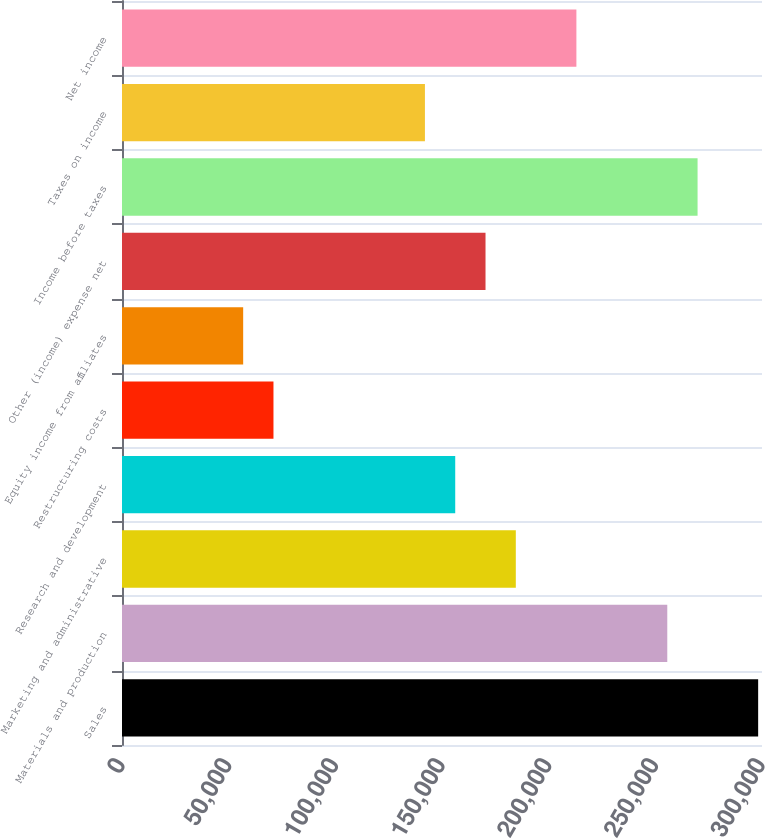<chart> <loc_0><loc_0><loc_500><loc_500><bar_chart><fcel>Sales<fcel>Materials and production<fcel>Marketing and administrative<fcel>Research and development<fcel>Restructuring costs<fcel>Equity income from affiliates<fcel>Other (income) expense net<fcel>Income before taxes<fcel>Taxes on income<fcel>Net income<nl><fcel>298198<fcel>255599<fcel>184599<fcel>156200<fcel>71000.9<fcel>56801.1<fcel>170400<fcel>269798<fcel>142000<fcel>212999<nl></chart> 